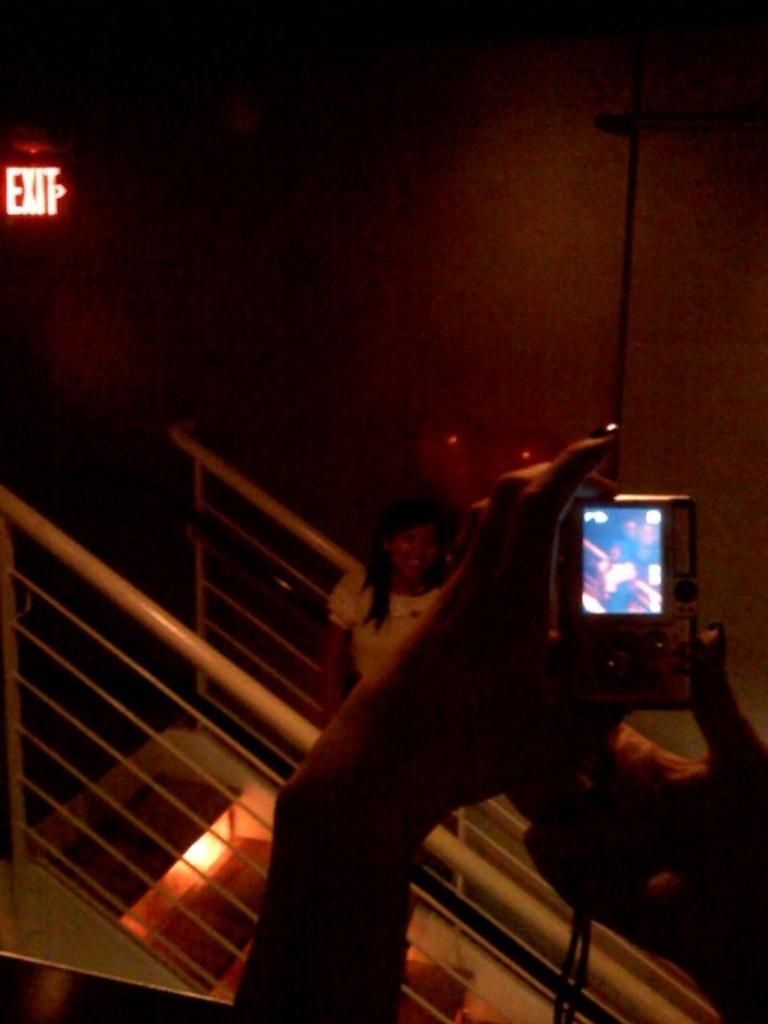Provide a one-sentence caption for the provided image. A woman taking a picture of someone next to an exit sign. 